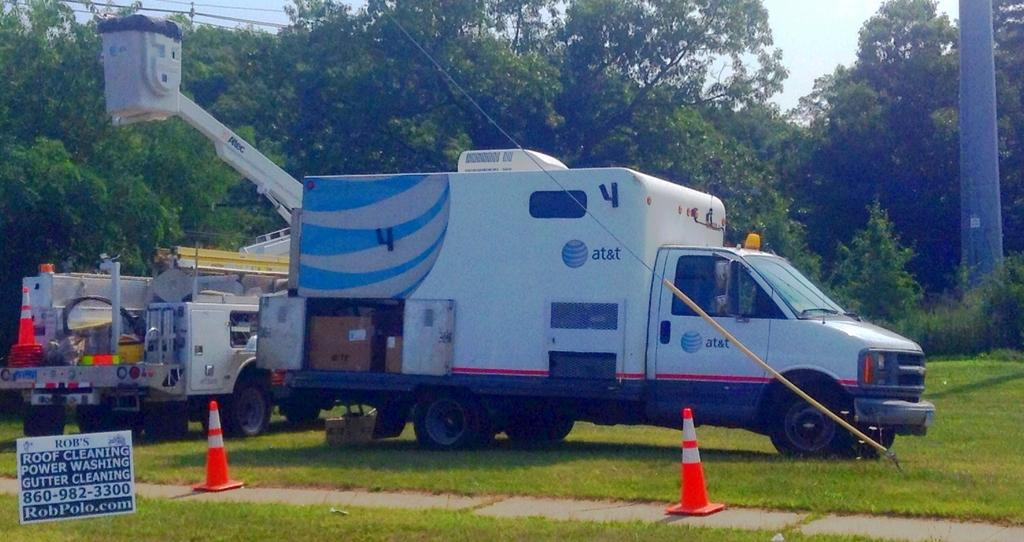<image>
Provide a brief description of the given image. At&T service trucks is parked next to a crane lift. 